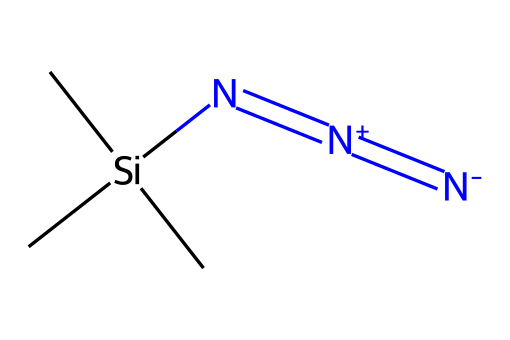What is the molecular formula of trimethylsilyl azide? The molecular formula can be derived from the SMILES representation. It contains three carbon (C) atoms, one silicon (Si), and four nitrogen (N) atoms, resulting in C3H9N3Si.
Answer: C3H9N3Si How many nitrogen atoms are in trimethylsilyl azide? By analyzing the SMILES, we can see that there are three nitrogen atoms present, indicated by the three occurrences of "N" in the structure.
Answer: 3 What functional group is present in trimethylsilyl azide? The presence of the azide group is shown in the structural formula, characterized by the three nitrogen atoms connected by double bonds and a nitrogen anion.
Answer: azide What is the degree of unsaturation in trimethylsilyl azide? The degree of unsaturation can be calculated based on the number of rings and π bonds. In this structure, we observe there are multiple double bonds (in the azide), indicating at least two degrees of unsaturation.
Answer: 2 What is the hybridization of the nitrogen atoms in the azide group? The nitrogen atoms in the azide group typically exhibit sp hybridization due to the presence of double bonds between them, leading to linear arrangement.
Answer: sp How many carbons are present in the structure of trimethylsilyl azide? From the structure shown in the SMILES, there are three carbon atoms represented by the "C" before the silicon atom and in the two methyl groups attached to silicon.
Answer: 3 